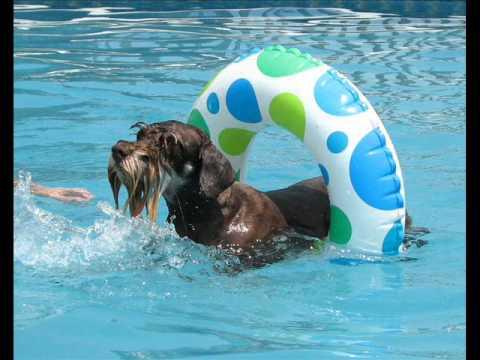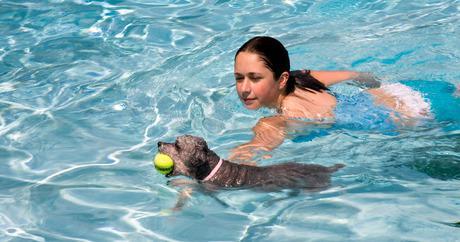The first image is the image on the left, the second image is the image on the right. Evaluate the accuracy of this statement regarding the images: "At least one dog is in an inner tube.". Is it true? Answer yes or no. Yes. The first image is the image on the left, the second image is the image on the right. Considering the images on both sides, is "There are at least four dogs in the pool." valid? Answer yes or no. No. 